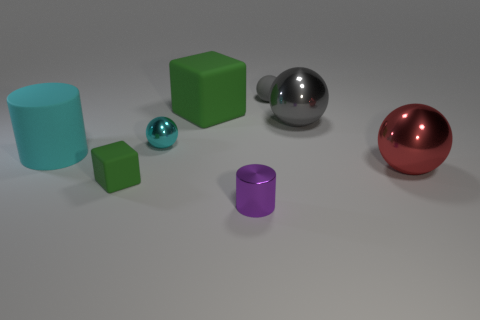Are there any other cubes that have the same color as the small rubber cube?
Your answer should be very brief. Yes. What material is the small object that is right of the tiny purple metallic cylinder?
Keep it short and to the point. Rubber. There is a ball that is made of the same material as the small cube; what color is it?
Your answer should be very brief. Gray. What number of gray objects have the same size as the purple cylinder?
Make the answer very short. 1. There is a cylinder left of the purple object; is it the same size as the small cyan metal ball?
Your response must be concise. No. There is a large thing that is behind the cyan metal sphere and on the right side of the small cylinder; what is its shape?
Offer a terse response. Sphere. Are there any tiny cyan balls behind the small green thing?
Make the answer very short. Yes. Does the large gray object have the same shape as the red object?
Give a very brief answer. Yes. Is the number of cyan things left of the tiny green cube the same as the number of red shiny balls that are to the right of the large cylinder?
Offer a very short reply. Yes. What number of other things are there of the same material as the purple object
Provide a short and direct response. 3. 